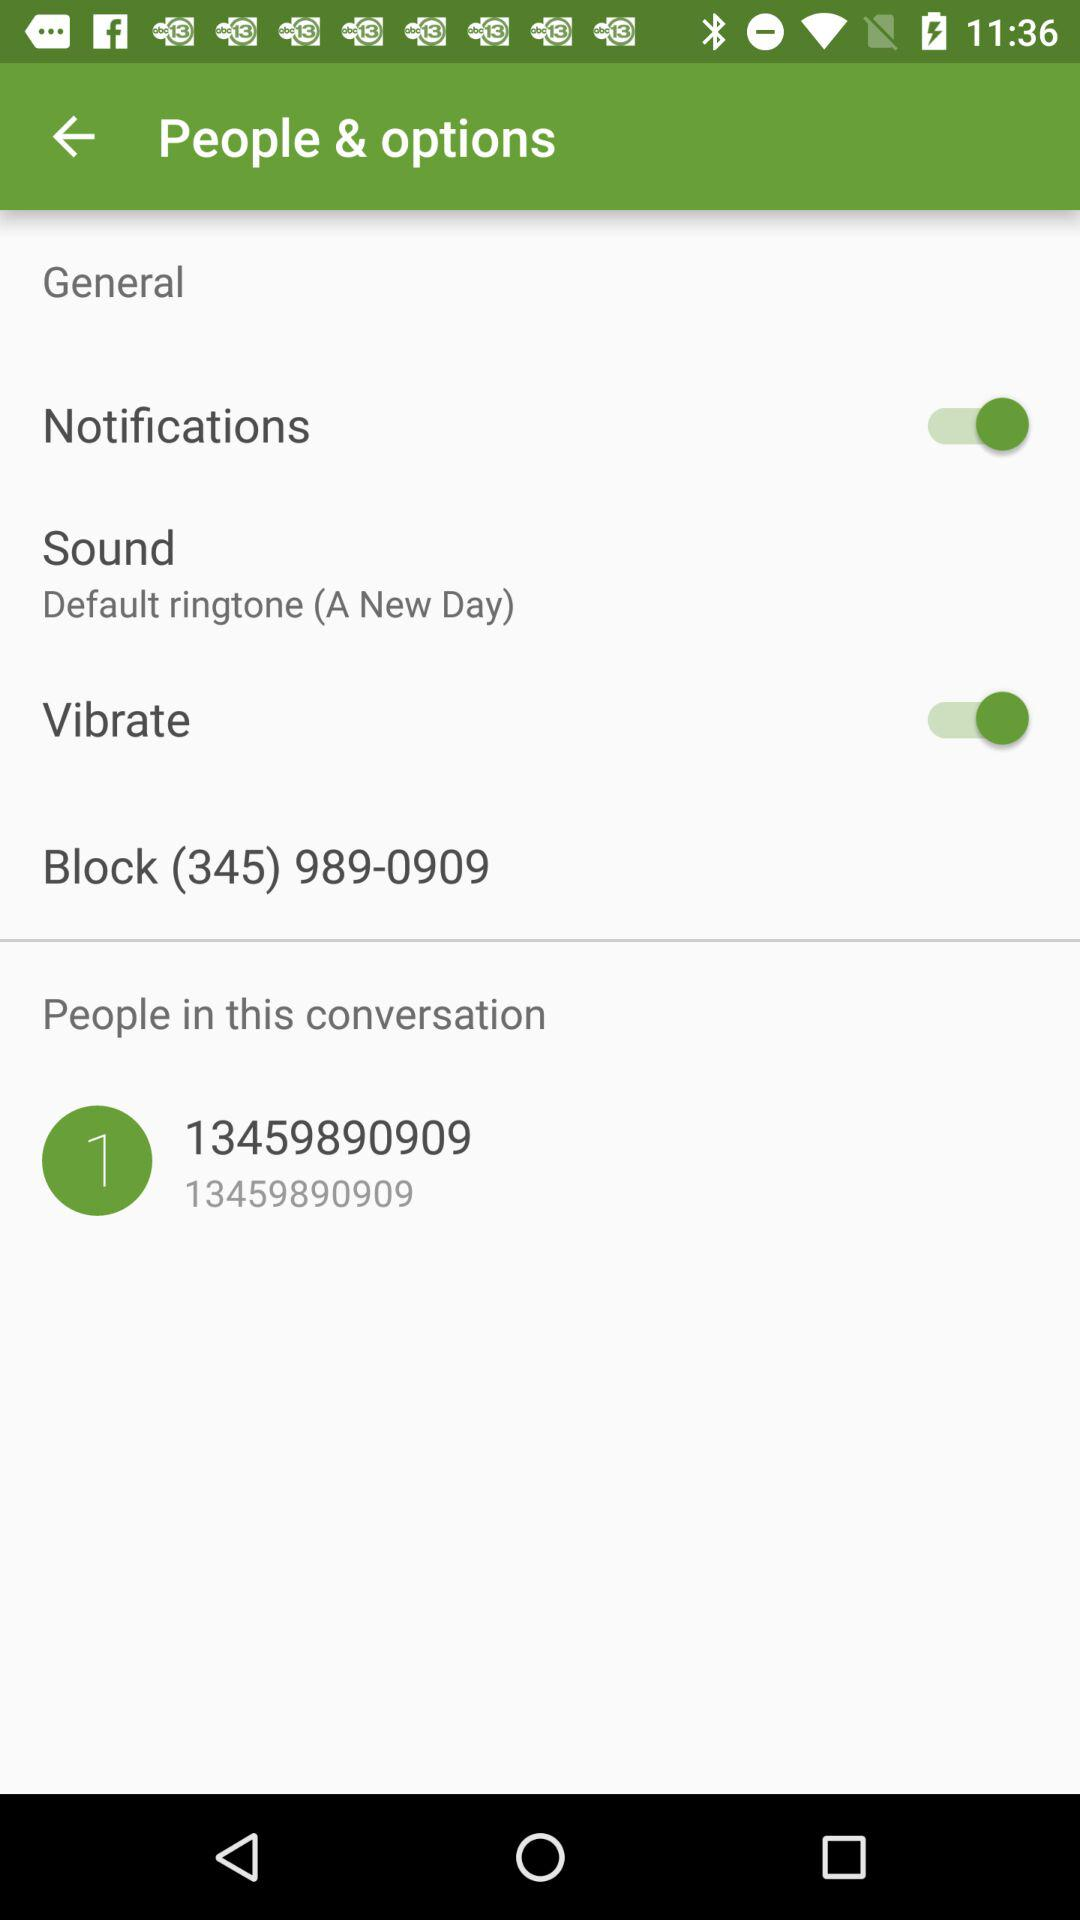What given number is blocked? The given blocked number is (345) 989-0909. 